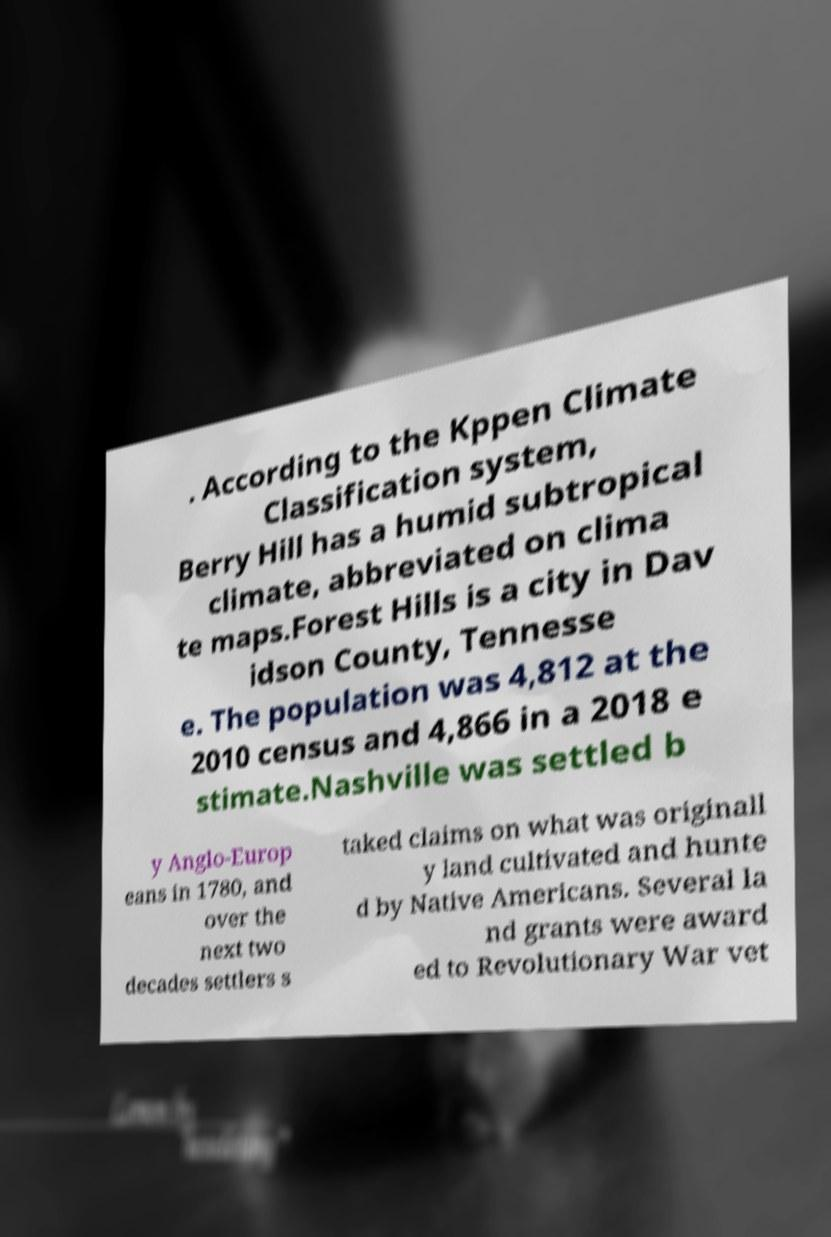I need the written content from this picture converted into text. Can you do that? . According to the Kppen Climate Classification system, Berry Hill has a humid subtropical climate, abbreviated on clima te maps.Forest Hills is a city in Dav idson County, Tennesse e. The population was 4,812 at the 2010 census and 4,866 in a 2018 e stimate.Nashville was settled b y Anglo-Europ eans in 1780, and over the next two decades settlers s taked claims on what was originall y land cultivated and hunte d by Native Americans. Several la nd grants were award ed to Revolutionary War vet 